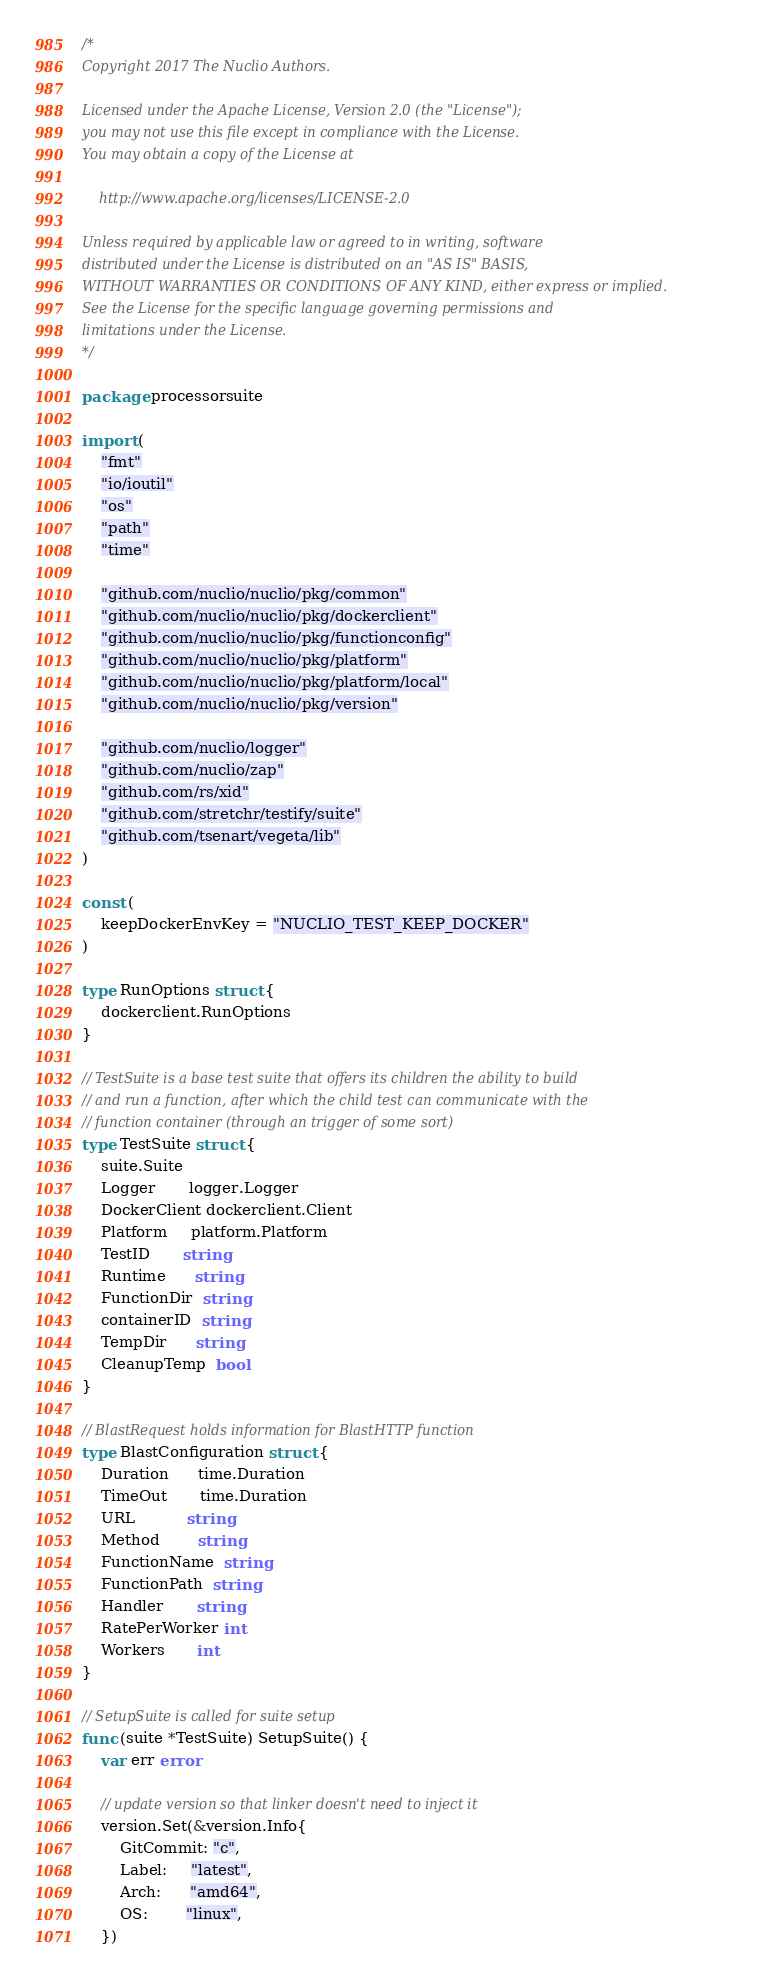<code> <loc_0><loc_0><loc_500><loc_500><_Go_>/*
Copyright 2017 The Nuclio Authors.

Licensed under the Apache License, Version 2.0 (the "License");
you may not use this file except in compliance with the License.
You may obtain a copy of the License at

    http://www.apache.org/licenses/LICENSE-2.0

Unless required by applicable law or agreed to in writing, software
distributed under the License is distributed on an "AS IS" BASIS,
WITHOUT WARRANTIES OR CONDITIONS OF ANY KIND, either express or implied.
See the License for the specific language governing permissions and
limitations under the License.
*/

package processorsuite

import (
	"fmt"
	"io/ioutil"
	"os"
	"path"
	"time"

	"github.com/nuclio/nuclio/pkg/common"
	"github.com/nuclio/nuclio/pkg/dockerclient"
	"github.com/nuclio/nuclio/pkg/functionconfig"
	"github.com/nuclio/nuclio/pkg/platform"
	"github.com/nuclio/nuclio/pkg/platform/local"
	"github.com/nuclio/nuclio/pkg/version"

	"github.com/nuclio/logger"
	"github.com/nuclio/zap"
	"github.com/rs/xid"
	"github.com/stretchr/testify/suite"
	"github.com/tsenart/vegeta/lib"
)

const (
	keepDockerEnvKey = "NUCLIO_TEST_KEEP_DOCKER"
)

type RunOptions struct {
	dockerclient.RunOptions
}

// TestSuite is a base test suite that offers its children the ability to build
// and run a function, after which the child test can communicate with the
// function container (through an trigger of some sort)
type TestSuite struct {
	suite.Suite
	Logger       logger.Logger
	DockerClient dockerclient.Client
	Platform     platform.Platform
	TestID       string
	Runtime      string
	FunctionDir  string
	containerID  string
	TempDir      string
	CleanupTemp  bool
}

// BlastRequest holds information for BlastHTTP function
type BlastConfiguration struct {
	Duration      time.Duration
	TimeOut       time.Duration
	URL           string
	Method        string
	FunctionName  string
	FunctionPath  string
	Handler       string
	RatePerWorker int
	Workers       int
}

// SetupSuite is called for suite setup
func (suite *TestSuite) SetupSuite() {
	var err error

	// update version so that linker doesn't need to inject it
	version.Set(&version.Info{
		GitCommit: "c",
		Label:     "latest",
		Arch:      "amd64",
		OS:        "linux",
	})
</code> 